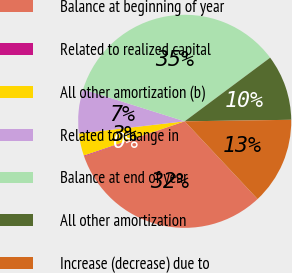<chart> <loc_0><loc_0><loc_500><loc_500><pie_chart><fcel>Balance at beginning of year<fcel>Related to realized capital<fcel>All other amortization (b)<fcel>Related to change in<fcel>Balance at end of year<fcel>All other amortization<fcel>Increase (decrease) due to<nl><fcel>31.67%<fcel>0.11%<fcel>3.39%<fcel>6.68%<fcel>34.95%<fcel>9.96%<fcel>13.24%<nl></chart> 